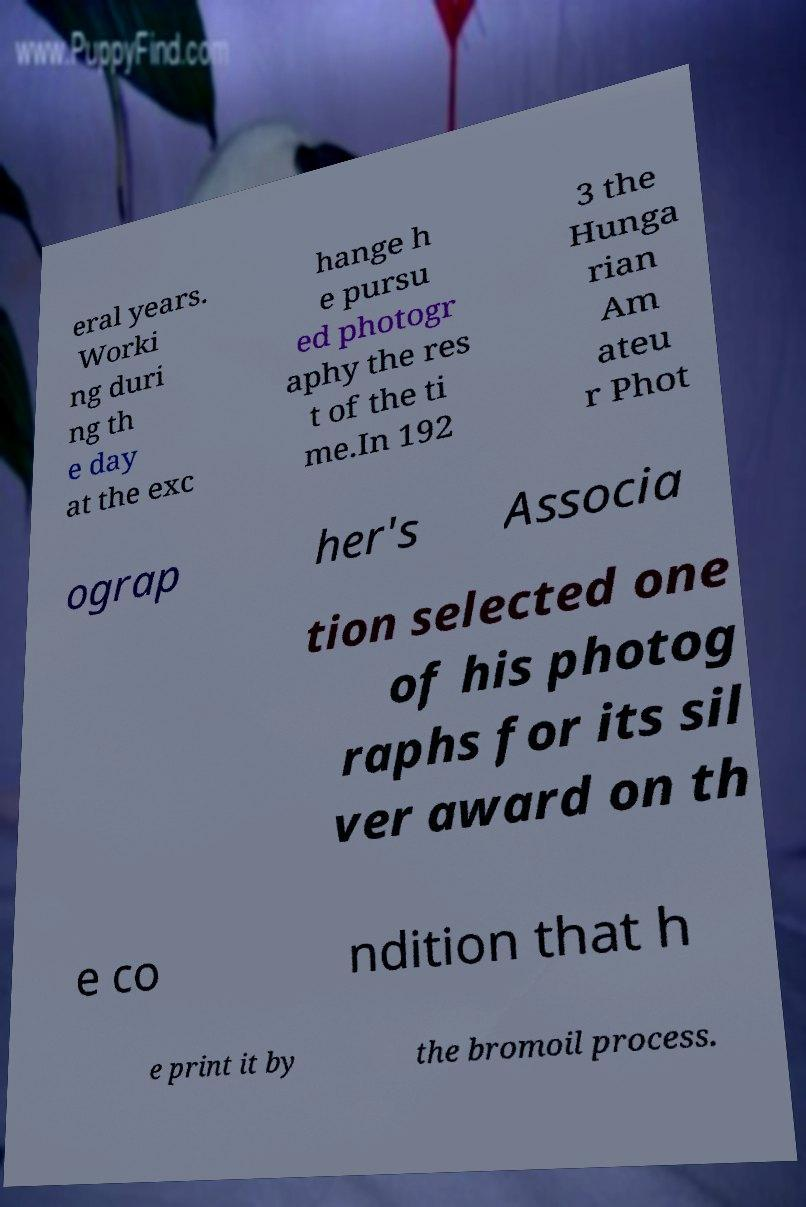What messages or text are displayed in this image? I need them in a readable, typed format. eral years. Worki ng duri ng th e day at the exc hange h e pursu ed photogr aphy the res t of the ti me.In 192 3 the Hunga rian Am ateu r Phot ograp her's Associa tion selected one of his photog raphs for its sil ver award on th e co ndition that h e print it by the bromoil process. 